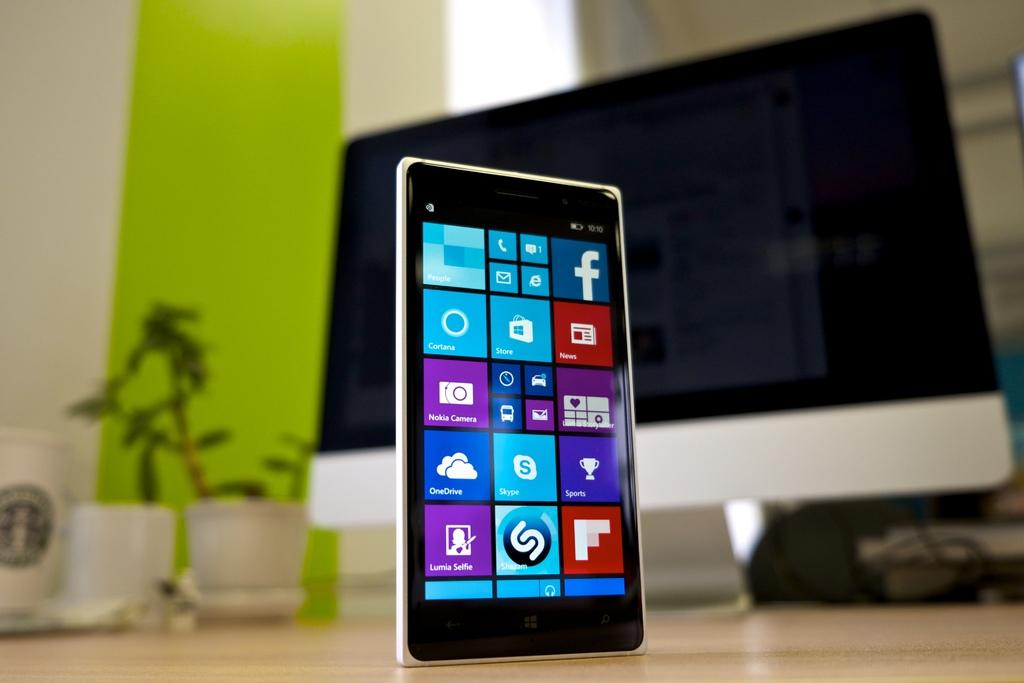<image>
Render a clear and concise summary of the photo. A windows phone screen displaying icons for facebook and shazam apps. 